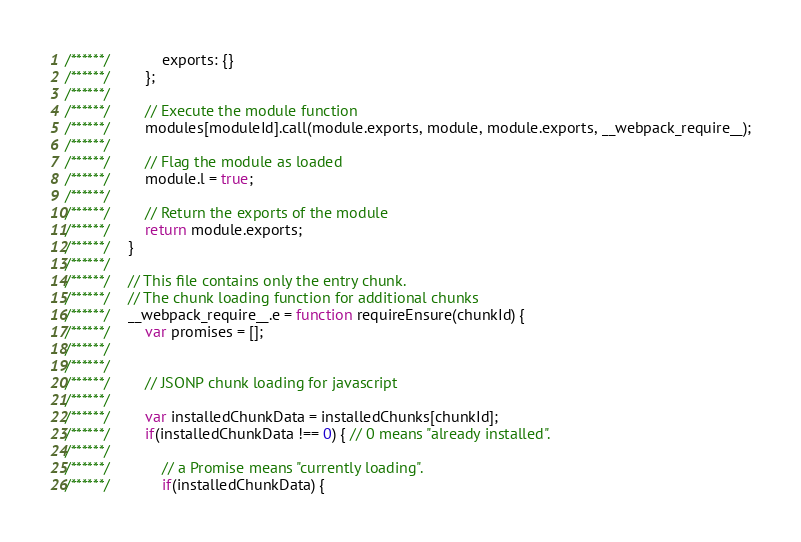Convert code to text. <code><loc_0><loc_0><loc_500><loc_500><_JavaScript_>/******/ 			exports: {}
/******/ 		};
/******/
/******/ 		// Execute the module function
/******/ 		modules[moduleId].call(module.exports, module, module.exports, __webpack_require__);
/******/
/******/ 		// Flag the module as loaded
/******/ 		module.l = true;
/******/
/******/ 		// Return the exports of the module
/******/ 		return module.exports;
/******/ 	}
/******/
/******/ 	// This file contains only the entry chunk.
/******/ 	// The chunk loading function for additional chunks
/******/ 	__webpack_require__.e = function requireEnsure(chunkId) {
/******/ 		var promises = [];
/******/
/******/
/******/ 		// JSONP chunk loading for javascript
/******/
/******/ 		var installedChunkData = installedChunks[chunkId];
/******/ 		if(installedChunkData !== 0) { // 0 means "already installed".
/******/
/******/ 			// a Promise means "currently loading".
/******/ 			if(installedChunkData) {</code> 